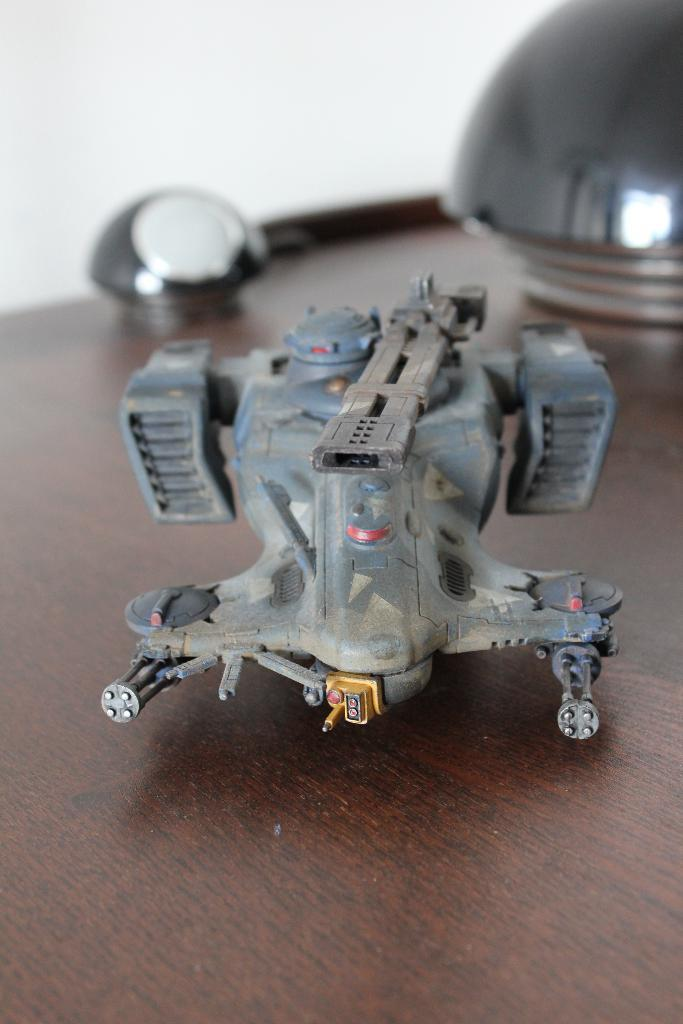What is the main subject in the center of the image? There is a toy in the center of the image. Where is the toy placed? The toy is placed on a table. What can be seen in the background of the image? There are objects visible in the background of the image. What type of structure is present in the background? There is a wall in the background of the image. How many marbles are rolling on the floor in the image? There are no marbles visible in the image; the main subject is a toy placed on a table. 